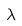Convert formula to latex. <formula><loc_0><loc_0><loc_500><loc_500>\lambda</formula> 